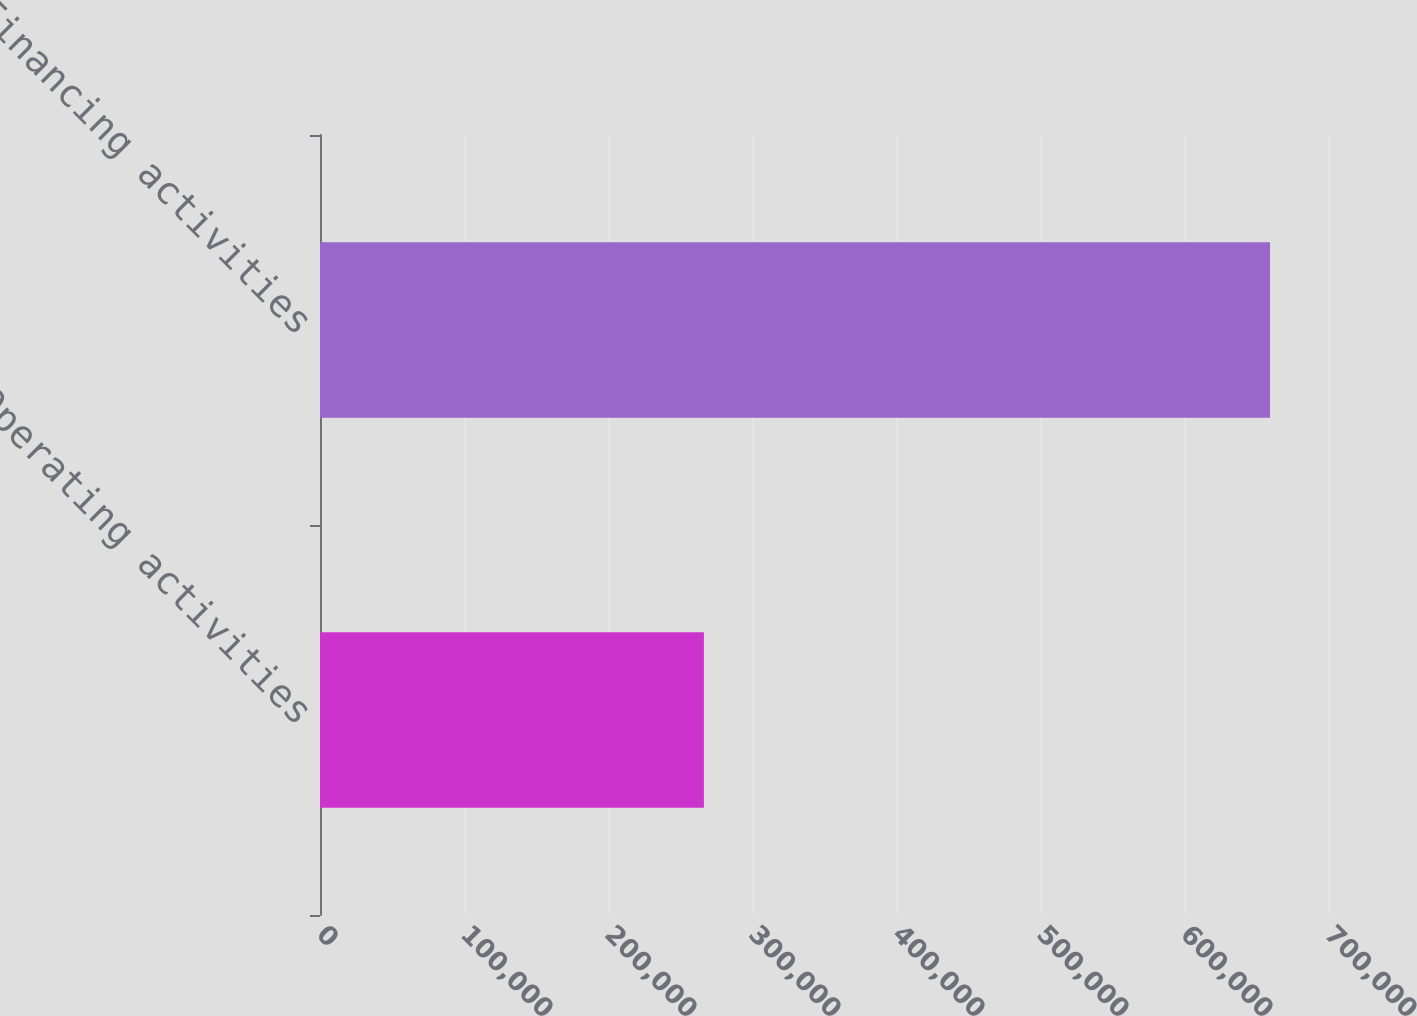<chart> <loc_0><loc_0><loc_500><loc_500><bar_chart><fcel>Operating activities<fcel>Financing activities<nl><fcel>266597<fcel>659760<nl></chart> 